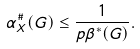Convert formula to latex. <formula><loc_0><loc_0><loc_500><loc_500>\alpha _ { X } ^ { \# } ( G ) \leq \frac { 1 } { p \beta ^ { * } ( G ) } .</formula> 